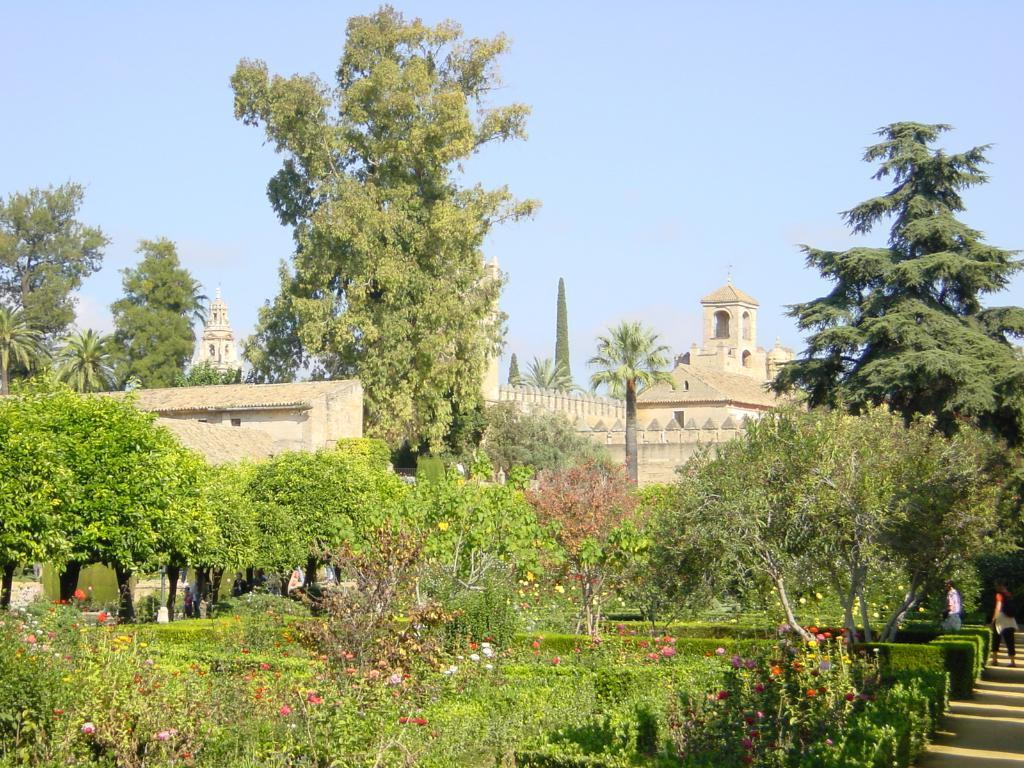What type of vegetation can be seen in the image? There are plants, flowers, and trees in the image. What type of structures are present in the image? There are buildings in the image. Are there any living beings in the image? Yes, there are people in the image. What can be seen in the background of the image? The sky is visible in the background of the image. How many people are washing their hands in the image? There is no indication in the image that anyone is washing their hands. Can you describe the smiles on the people's faces in the image? There is no mention of smiles on the people's faces in the image. 